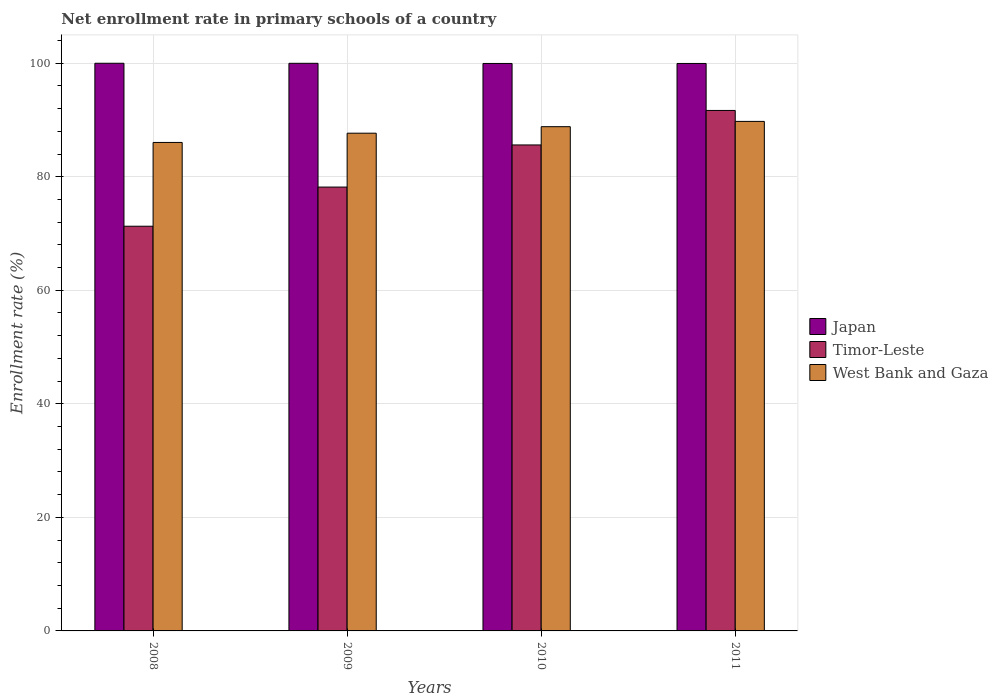How many groups of bars are there?
Ensure brevity in your answer.  4. Are the number of bars per tick equal to the number of legend labels?
Ensure brevity in your answer.  Yes. Are the number of bars on each tick of the X-axis equal?
Provide a short and direct response. Yes. How many bars are there on the 2nd tick from the left?
Your response must be concise. 3. How many bars are there on the 2nd tick from the right?
Offer a terse response. 3. What is the enrollment rate in primary schools in West Bank and Gaza in 2010?
Offer a terse response. 88.82. Across all years, what is the maximum enrollment rate in primary schools in Japan?
Give a very brief answer. 99.99. Across all years, what is the minimum enrollment rate in primary schools in Timor-Leste?
Make the answer very short. 71.28. In which year was the enrollment rate in primary schools in Japan maximum?
Ensure brevity in your answer.  2008. In which year was the enrollment rate in primary schools in Japan minimum?
Keep it short and to the point. 2011. What is the total enrollment rate in primary schools in West Bank and Gaza in the graph?
Your response must be concise. 352.27. What is the difference between the enrollment rate in primary schools in West Bank and Gaza in 2008 and that in 2011?
Provide a succinct answer. -3.71. What is the difference between the enrollment rate in primary schools in Timor-Leste in 2011 and the enrollment rate in primary schools in West Bank and Gaza in 2010?
Keep it short and to the point. 2.86. What is the average enrollment rate in primary schools in West Bank and Gaza per year?
Your response must be concise. 88.07. In the year 2009, what is the difference between the enrollment rate in primary schools in West Bank and Gaza and enrollment rate in primary schools in Japan?
Provide a succinct answer. -12.31. In how many years, is the enrollment rate in primary schools in Timor-Leste greater than 44 %?
Offer a very short reply. 4. What is the ratio of the enrollment rate in primary schools in Japan in 2008 to that in 2010?
Provide a succinct answer. 1. What is the difference between the highest and the second highest enrollment rate in primary schools in Japan?
Offer a very short reply. 0.01. What is the difference between the highest and the lowest enrollment rate in primary schools in West Bank and Gaza?
Provide a short and direct response. 3.71. In how many years, is the enrollment rate in primary schools in Timor-Leste greater than the average enrollment rate in primary schools in Timor-Leste taken over all years?
Provide a short and direct response. 2. Is the sum of the enrollment rate in primary schools in Timor-Leste in 2009 and 2011 greater than the maximum enrollment rate in primary schools in West Bank and Gaza across all years?
Offer a very short reply. Yes. What does the 3rd bar from the left in 2009 represents?
Offer a very short reply. West Bank and Gaza. What does the 2nd bar from the right in 2010 represents?
Make the answer very short. Timor-Leste. How many bars are there?
Your answer should be compact. 12. What is the difference between two consecutive major ticks on the Y-axis?
Your response must be concise. 20. Does the graph contain any zero values?
Your answer should be very brief. No. Does the graph contain grids?
Offer a very short reply. Yes. What is the title of the graph?
Provide a succinct answer. Net enrollment rate in primary schools of a country. What is the label or title of the Y-axis?
Your answer should be compact. Enrollment rate (%). What is the Enrollment rate (%) in Japan in 2008?
Make the answer very short. 99.99. What is the Enrollment rate (%) of Timor-Leste in 2008?
Your answer should be very brief. 71.28. What is the Enrollment rate (%) in West Bank and Gaza in 2008?
Provide a short and direct response. 86.04. What is the Enrollment rate (%) in Japan in 2009?
Provide a succinct answer. 99.98. What is the Enrollment rate (%) of Timor-Leste in 2009?
Make the answer very short. 78.18. What is the Enrollment rate (%) of West Bank and Gaza in 2009?
Offer a very short reply. 87.67. What is the Enrollment rate (%) in Japan in 2010?
Offer a terse response. 99.95. What is the Enrollment rate (%) in Timor-Leste in 2010?
Your answer should be compact. 85.6. What is the Enrollment rate (%) in West Bank and Gaza in 2010?
Your answer should be very brief. 88.82. What is the Enrollment rate (%) in Japan in 2011?
Provide a succinct answer. 99.95. What is the Enrollment rate (%) in Timor-Leste in 2011?
Your answer should be very brief. 91.67. What is the Enrollment rate (%) in West Bank and Gaza in 2011?
Your answer should be compact. 89.75. Across all years, what is the maximum Enrollment rate (%) in Japan?
Provide a short and direct response. 99.99. Across all years, what is the maximum Enrollment rate (%) in Timor-Leste?
Give a very brief answer. 91.67. Across all years, what is the maximum Enrollment rate (%) in West Bank and Gaza?
Your answer should be very brief. 89.75. Across all years, what is the minimum Enrollment rate (%) of Japan?
Offer a terse response. 99.95. Across all years, what is the minimum Enrollment rate (%) of Timor-Leste?
Your answer should be compact. 71.28. Across all years, what is the minimum Enrollment rate (%) in West Bank and Gaza?
Provide a succinct answer. 86.04. What is the total Enrollment rate (%) in Japan in the graph?
Keep it short and to the point. 399.86. What is the total Enrollment rate (%) in Timor-Leste in the graph?
Offer a terse response. 326.73. What is the total Enrollment rate (%) of West Bank and Gaza in the graph?
Keep it short and to the point. 352.27. What is the difference between the Enrollment rate (%) of Japan in 2008 and that in 2009?
Keep it short and to the point. 0.01. What is the difference between the Enrollment rate (%) in Timor-Leste in 2008 and that in 2009?
Provide a short and direct response. -6.9. What is the difference between the Enrollment rate (%) of West Bank and Gaza in 2008 and that in 2009?
Provide a succinct answer. -1.63. What is the difference between the Enrollment rate (%) of Japan in 2008 and that in 2010?
Offer a very short reply. 0.04. What is the difference between the Enrollment rate (%) of Timor-Leste in 2008 and that in 2010?
Your answer should be compact. -14.32. What is the difference between the Enrollment rate (%) of West Bank and Gaza in 2008 and that in 2010?
Your response must be concise. -2.78. What is the difference between the Enrollment rate (%) of Japan in 2008 and that in 2011?
Provide a succinct answer. 0.04. What is the difference between the Enrollment rate (%) in Timor-Leste in 2008 and that in 2011?
Your answer should be compact. -20.39. What is the difference between the Enrollment rate (%) of West Bank and Gaza in 2008 and that in 2011?
Offer a very short reply. -3.71. What is the difference between the Enrollment rate (%) of Japan in 2009 and that in 2010?
Offer a terse response. 0.03. What is the difference between the Enrollment rate (%) in Timor-Leste in 2009 and that in 2010?
Your answer should be very brief. -7.42. What is the difference between the Enrollment rate (%) of West Bank and Gaza in 2009 and that in 2010?
Provide a short and direct response. -1.15. What is the difference between the Enrollment rate (%) in Japan in 2009 and that in 2011?
Make the answer very short. 0.03. What is the difference between the Enrollment rate (%) of Timor-Leste in 2009 and that in 2011?
Keep it short and to the point. -13.5. What is the difference between the Enrollment rate (%) in West Bank and Gaza in 2009 and that in 2011?
Ensure brevity in your answer.  -2.08. What is the difference between the Enrollment rate (%) in Japan in 2010 and that in 2011?
Your answer should be very brief. 0. What is the difference between the Enrollment rate (%) in Timor-Leste in 2010 and that in 2011?
Your answer should be very brief. -6.08. What is the difference between the Enrollment rate (%) in West Bank and Gaza in 2010 and that in 2011?
Ensure brevity in your answer.  -0.93. What is the difference between the Enrollment rate (%) of Japan in 2008 and the Enrollment rate (%) of Timor-Leste in 2009?
Your response must be concise. 21.81. What is the difference between the Enrollment rate (%) of Japan in 2008 and the Enrollment rate (%) of West Bank and Gaza in 2009?
Give a very brief answer. 12.32. What is the difference between the Enrollment rate (%) of Timor-Leste in 2008 and the Enrollment rate (%) of West Bank and Gaza in 2009?
Provide a short and direct response. -16.39. What is the difference between the Enrollment rate (%) of Japan in 2008 and the Enrollment rate (%) of Timor-Leste in 2010?
Make the answer very short. 14.39. What is the difference between the Enrollment rate (%) of Japan in 2008 and the Enrollment rate (%) of West Bank and Gaza in 2010?
Offer a terse response. 11.17. What is the difference between the Enrollment rate (%) of Timor-Leste in 2008 and the Enrollment rate (%) of West Bank and Gaza in 2010?
Your answer should be compact. -17.54. What is the difference between the Enrollment rate (%) in Japan in 2008 and the Enrollment rate (%) in Timor-Leste in 2011?
Offer a terse response. 8.31. What is the difference between the Enrollment rate (%) of Japan in 2008 and the Enrollment rate (%) of West Bank and Gaza in 2011?
Offer a very short reply. 10.24. What is the difference between the Enrollment rate (%) in Timor-Leste in 2008 and the Enrollment rate (%) in West Bank and Gaza in 2011?
Your response must be concise. -18.47. What is the difference between the Enrollment rate (%) of Japan in 2009 and the Enrollment rate (%) of Timor-Leste in 2010?
Keep it short and to the point. 14.38. What is the difference between the Enrollment rate (%) in Japan in 2009 and the Enrollment rate (%) in West Bank and Gaza in 2010?
Offer a very short reply. 11.16. What is the difference between the Enrollment rate (%) of Timor-Leste in 2009 and the Enrollment rate (%) of West Bank and Gaza in 2010?
Ensure brevity in your answer.  -10.64. What is the difference between the Enrollment rate (%) in Japan in 2009 and the Enrollment rate (%) in Timor-Leste in 2011?
Keep it short and to the point. 8.3. What is the difference between the Enrollment rate (%) of Japan in 2009 and the Enrollment rate (%) of West Bank and Gaza in 2011?
Offer a terse response. 10.23. What is the difference between the Enrollment rate (%) in Timor-Leste in 2009 and the Enrollment rate (%) in West Bank and Gaza in 2011?
Your answer should be very brief. -11.57. What is the difference between the Enrollment rate (%) in Japan in 2010 and the Enrollment rate (%) in Timor-Leste in 2011?
Offer a terse response. 8.28. What is the difference between the Enrollment rate (%) of Japan in 2010 and the Enrollment rate (%) of West Bank and Gaza in 2011?
Offer a very short reply. 10.2. What is the difference between the Enrollment rate (%) in Timor-Leste in 2010 and the Enrollment rate (%) in West Bank and Gaza in 2011?
Offer a terse response. -4.15. What is the average Enrollment rate (%) of Japan per year?
Your answer should be compact. 99.97. What is the average Enrollment rate (%) in Timor-Leste per year?
Your response must be concise. 81.68. What is the average Enrollment rate (%) in West Bank and Gaza per year?
Ensure brevity in your answer.  88.07. In the year 2008, what is the difference between the Enrollment rate (%) of Japan and Enrollment rate (%) of Timor-Leste?
Provide a succinct answer. 28.7. In the year 2008, what is the difference between the Enrollment rate (%) in Japan and Enrollment rate (%) in West Bank and Gaza?
Give a very brief answer. 13.95. In the year 2008, what is the difference between the Enrollment rate (%) in Timor-Leste and Enrollment rate (%) in West Bank and Gaza?
Provide a succinct answer. -14.76. In the year 2009, what is the difference between the Enrollment rate (%) in Japan and Enrollment rate (%) in Timor-Leste?
Keep it short and to the point. 21.8. In the year 2009, what is the difference between the Enrollment rate (%) of Japan and Enrollment rate (%) of West Bank and Gaza?
Your response must be concise. 12.31. In the year 2009, what is the difference between the Enrollment rate (%) in Timor-Leste and Enrollment rate (%) in West Bank and Gaza?
Your response must be concise. -9.49. In the year 2010, what is the difference between the Enrollment rate (%) in Japan and Enrollment rate (%) in Timor-Leste?
Your answer should be very brief. 14.35. In the year 2010, what is the difference between the Enrollment rate (%) in Japan and Enrollment rate (%) in West Bank and Gaza?
Your response must be concise. 11.13. In the year 2010, what is the difference between the Enrollment rate (%) of Timor-Leste and Enrollment rate (%) of West Bank and Gaza?
Provide a short and direct response. -3.22. In the year 2011, what is the difference between the Enrollment rate (%) of Japan and Enrollment rate (%) of Timor-Leste?
Offer a very short reply. 8.28. In the year 2011, what is the difference between the Enrollment rate (%) in Japan and Enrollment rate (%) in West Bank and Gaza?
Your response must be concise. 10.2. In the year 2011, what is the difference between the Enrollment rate (%) of Timor-Leste and Enrollment rate (%) of West Bank and Gaza?
Provide a succinct answer. 1.93. What is the ratio of the Enrollment rate (%) in Timor-Leste in 2008 to that in 2009?
Give a very brief answer. 0.91. What is the ratio of the Enrollment rate (%) in West Bank and Gaza in 2008 to that in 2009?
Your answer should be very brief. 0.98. What is the ratio of the Enrollment rate (%) of Timor-Leste in 2008 to that in 2010?
Give a very brief answer. 0.83. What is the ratio of the Enrollment rate (%) of West Bank and Gaza in 2008 to that in 2010?
Ensure brevity in your answer.  0.97. What is the ratio of the Enrollment rate (%) of Japan in 2008 to that in 2011?
Provide a short and direct response. 1. What is the ratio of the Enrollment rate (%) of Timor-Leste in 2008 to that in 2011?
Your answer should be compact. 0.78. What is the ratio of the Enrollment rate (%) in West Bank and Gaza in 2008 to that in 2011?
Your answer should be compact. 0.96. What is the ratio of the Enrollment rate (%) of Japan in 2009 to that in 2010?
Provide a short and direct response. 1. What is the ratio of the Enrollment rate (%) of Timor-Leste in 2009 to that in 2010?
Ensure brevity in your answer.  0.91. What is the ratio of the Enrollment rate (%) of West Bank and Gaza in 2009 to that in 2010?
Give a very brief answer. 0.99. What is the ratio of the Enrollment rate (%) in Japan in 2009 to that in 2011?
Give a very brief answer. 1. What is the ratio of the Enrollment rate (%) of Timor-Leste in 2009 to that in 2011?
Provide a succinct answer. 0.85. What is the ratio of the Enrollment rate (%) in West Bank and Gaza in 2009 to that in 2011?
Offer a terse response. 0.98. What is the ratio of the Enrollment rate (%) of Timor-Leste in 2010 to that in 2011?
Make the answer very short. 0.93. What is the difference between the highest and the second highest Enrollment rate (%) in Japan?
Keep it short and to the point. 0.01. What is the difference between the highest and the second highest Enrollment rate (%) in Timor-Leste?
Offer a very short reply. 6.08. What is the difference between the highest and the second highest Enrollment rate (%) of West Bank and Gaza?
Provide a succinct answer. 0.93. What is the difference between the highest and the lowest Enrollment rate (%) in Japan?
Make the answer very short. 0.04. What is the difference between the highest and the lowest Enrollment rate (%) of Timor-Leste?
Your response must be concise. 20.39. What is the difference between the highest and the lowest Enrollment rate (%) in West Bank and Gaza?
Make the answer very short. 3.71. 